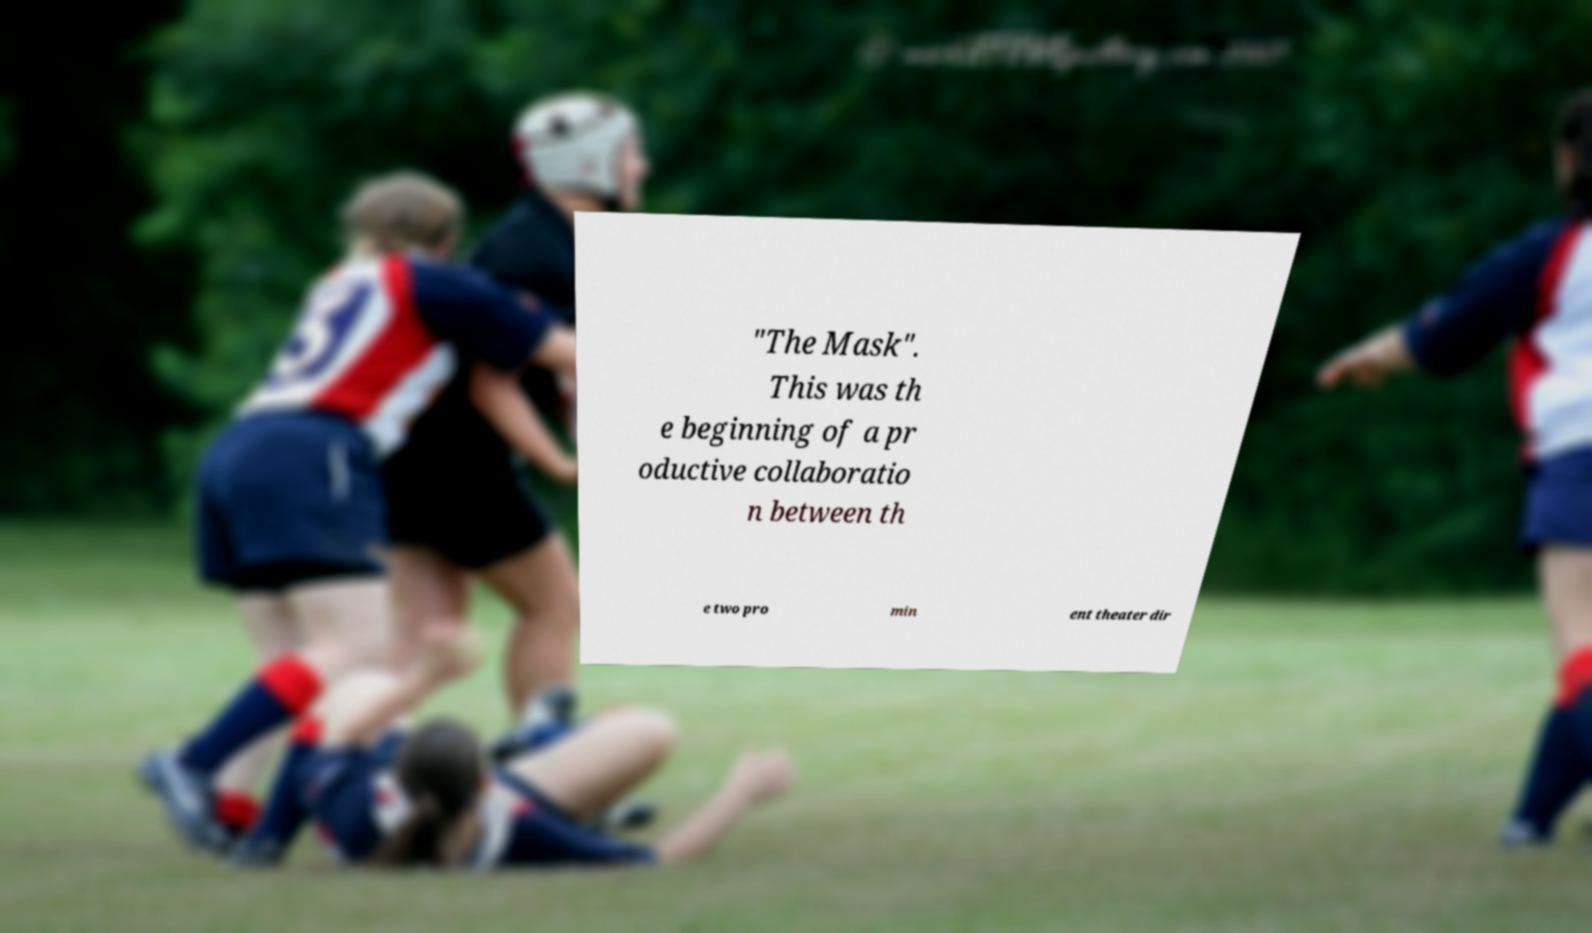Can you accurately transcribe the text from the provided image for me? "The Mask". This was th e beginning of a pr oductive collaboratio n between th e two pro min ent theater dir 